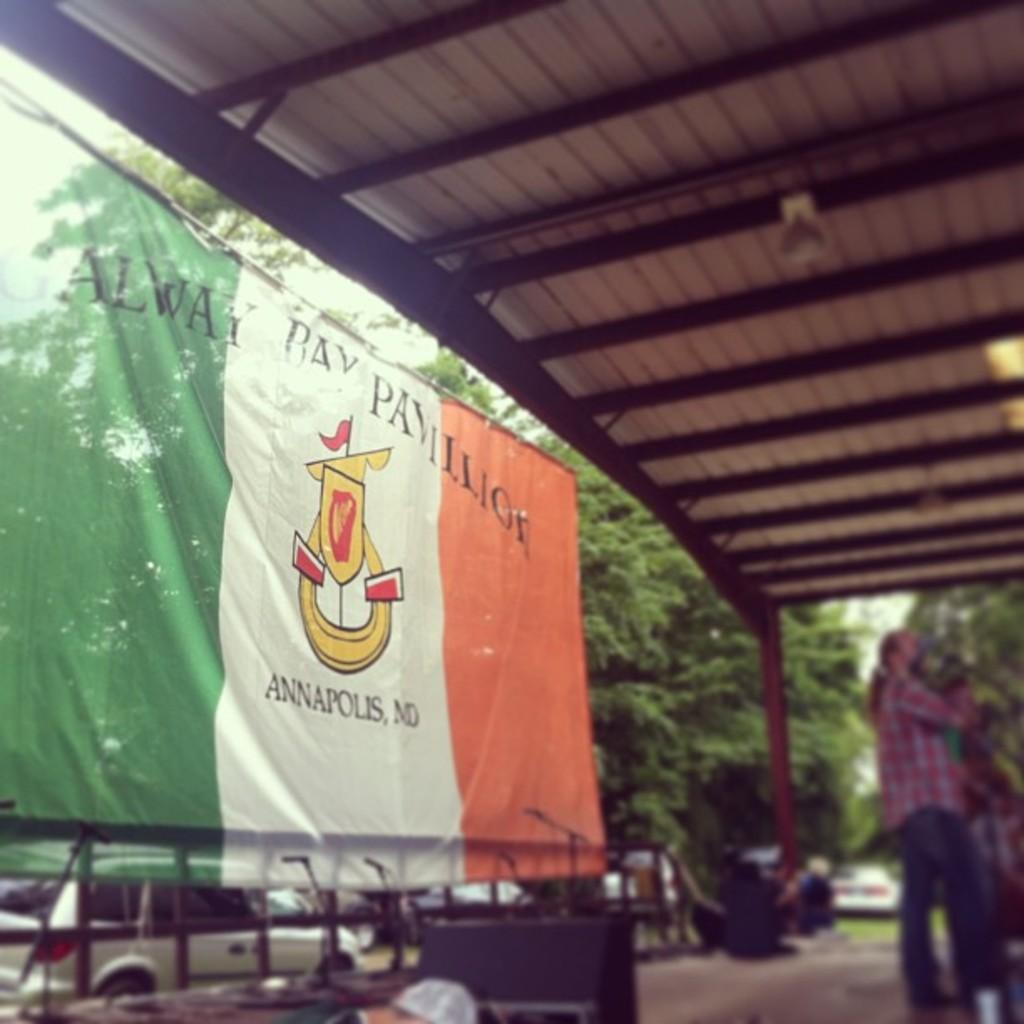Who or what can be seen in the image? There are people in the image. What else is present in the image besides people? There are vehicles, microphone stands, a flag, a shed, and trees in the background. The sky is also visible in the background. Can you describe the vehicles in the image? The provided facts do not specify the type or characteristics of the vehicles. What is the purpose of the microphone stands in the image? The presence of microphone stands suggests that there might be a performance or event taking place. What type of bone can be seen in the image? There is no bone present in the image. What kind of rock is visible in the background of the image? There is no rock visible in the image; only trees and the sky are present in the background. 